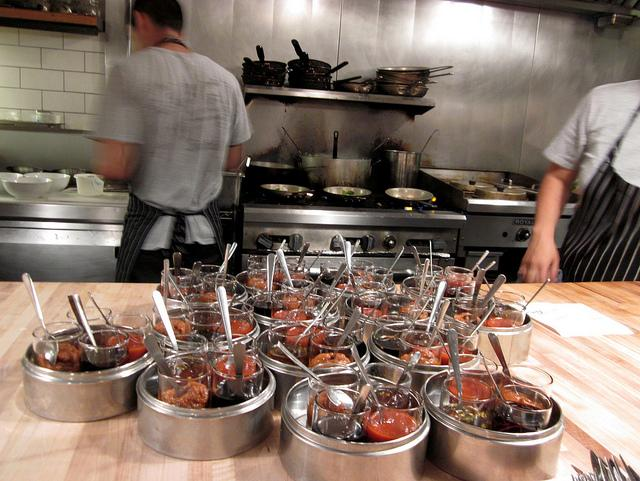Inside silver round large cans what is seen here in profusion? Please explain your reasoning. condiments. The cups are full of liquid which requires spoons to serve. 